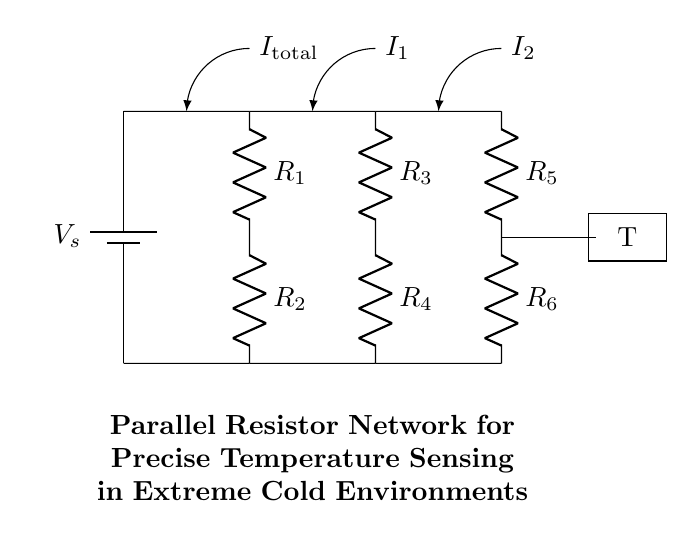What is the total voltage supplied by the battery? The circuit diagram shows a battery labeled as Vs, which represents the supply voltage for the entire circuit. The exact numerical value is not provided in the diagram; however, it is indicated as a voltage source in the schematic.
Answer: Vs What are the resistances in the parallel network? The circuit includes resistors labeled as R3, R4, R5, and R6. These resistors are in parallel, which is a critical feature of this design aimed at creating a current divider for temperature sensing.
Answer: R3, R4, R5, R6 How many resistors are used in the circuit? There are a total of six resistors in the circuit: R1 and R2 in series, and R3, R4, R5, and R6 in parallel. The resistors contribute to the current distribution needed for accurate temperature measurement in extreme environments.
Answer: Six What does the symbol 'T' represent in the circuit? The 'T' symbol in the circuit represents a temperature sensor. It is placed after the network of resistors, indicating that it is used to measure the temperature based on the voltage drop across the resistors in the parallel network.
Answer: Temperature sensor What is the current labeled as 'I1' connected to? The current labeled 'I1' is the branch current flowing through the resistors in the parallel portion of the circuit, specifically between points where R3 and R4 are connected. This is critical for analyzing how temperature affects current distribution.
Answer: R3 and R4 What happens to the total current in the parallel resistors? The total current entering the parallel resistors divides into different branches, represented as I1 and I2. This division is essential for achieving the precise measurements required in unstable conditions like extreme cold.
Answer: It divides into I1 and I2 